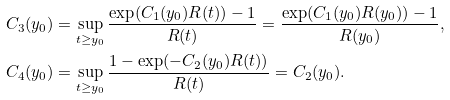<formula> <loc_0><loc_0><loc_500><loc_500>C _ { 3 } ( y _ { 0 } ) & = \sup _ { t \geq y _ { 0 } } \frac { \exp ( C _ { 1 } ( y _ { 0 } ) R ( t ) ) - 1 } { R ( t ) } = \frac { \exp ( C _ { 1 } ( y _ { 0 } ) R ( y _ { 0 } ) ) - 1 } { R ( y _ { 0 } ) } , \\ C _ { 4 } ( y _ { 0 } ) & = \sup _ { t \geq y _ { 0 } } \frac { 1 - \exp ( - C _ { 2 } ( y _ { 0 } ) R ( t ) ) } { R ( t ) } = C _ { 2 } ( y _ { 0 } ) .</formula> 